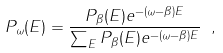Convert formula to latex. <formula><loc_0><loc_0><loc_500><loc_500>P _ { \omega } ( E ) = \frac { P _ { \beta } ( E ) e ^ { - ( \omega - \beta ) E } } { \sum _ { E } P _ { \beta } ( E ) e ^ { - ( \omega - \beta ) E } } \ ,</formula> 